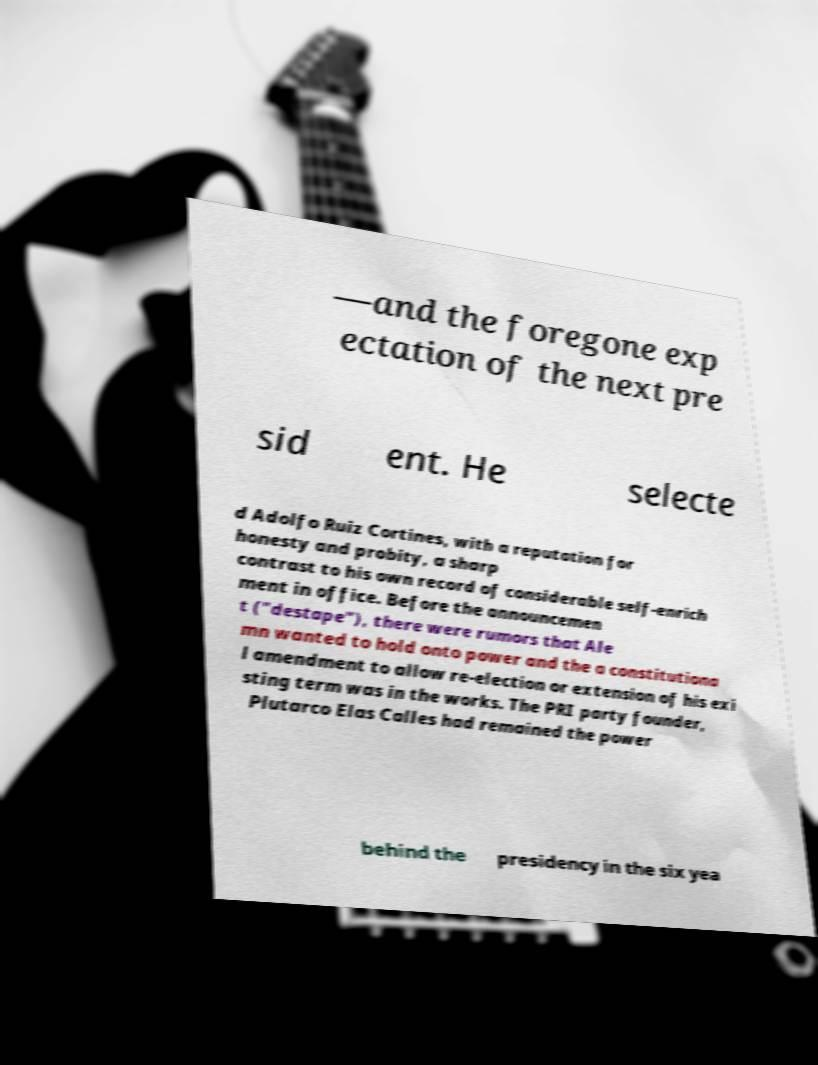Can you accurately transcribe the text from the provided image for me? —and the foregone exp ectation of the next pre sid ent. He selecte d Adolfo Ruiz Cortines, with a reputation for honesty and probity, a sharp contrast to his own record of considerable self-enrich ment in office. Before the announcemen t ("destape"), there were rumors that Ale mn wanted to hold onto power and the a constitutiona l amendment to allow re-election or extension of his exi sting term was in the works. The PRI party founder, Plutarco Elas Calles had remained the power behind the presidency in the six yea 